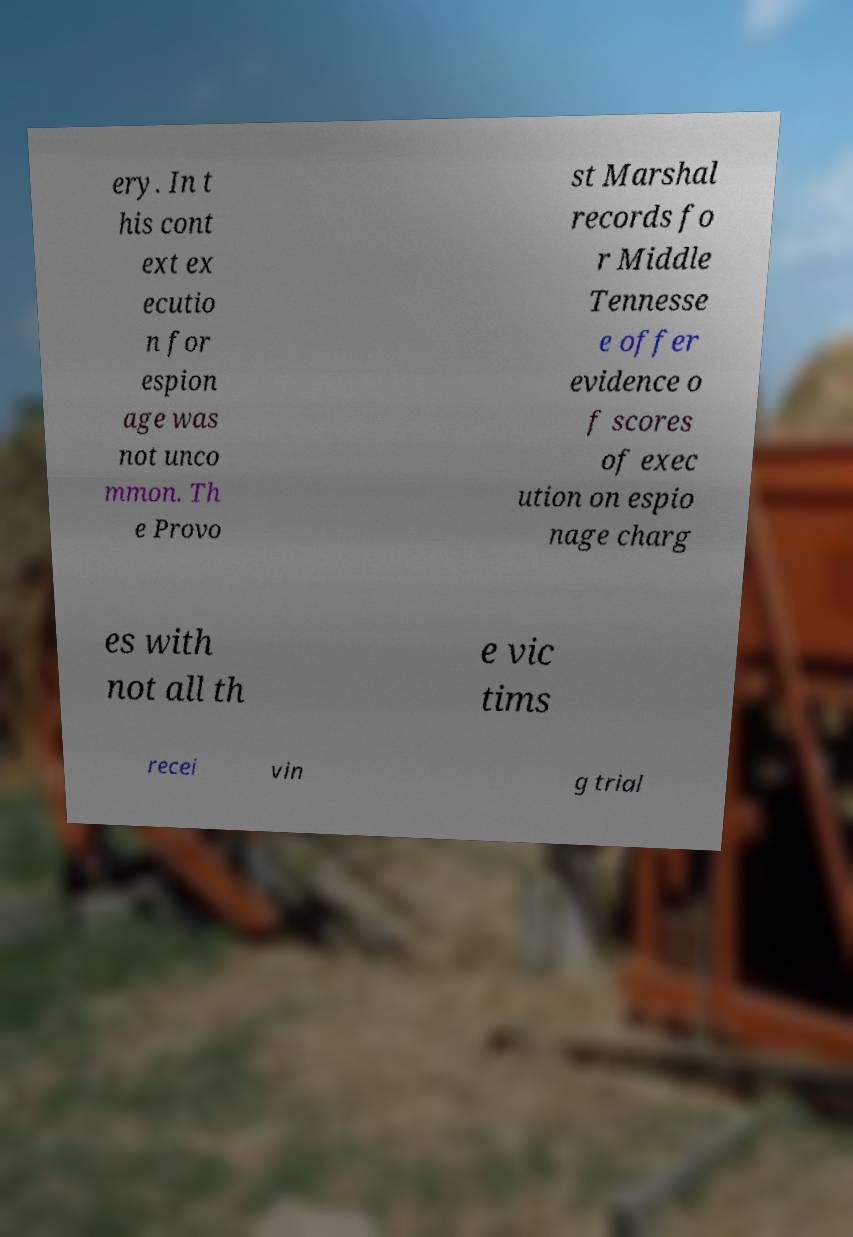There's text embedded in this image that I need extracted. Can you transcribe it verbatim? ery. In t his cont ext ex ecutio n for espion age was not unco mmon. Th e Provo st Marshal records fo r Middle Tennesse e offer evidence o f scores of exec ution on espio nage charg es with not all th e vic tims recei vin g trial 